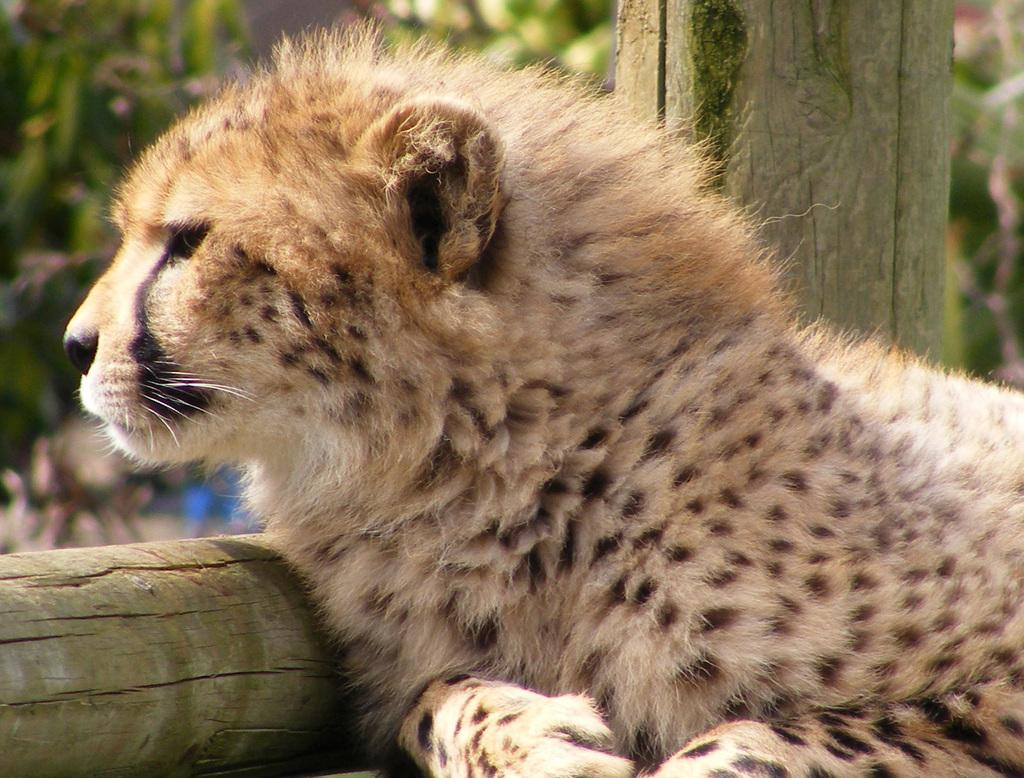What animal is the main subject of the image? There is a leopard in the image. What surface is the leopard on? The leopard is on wood. Can you describe any other objects or features in the image? There is a stem in the top right of the image. How would you describe the overall appearance of the image? The background of the image is blurred. What group of people is shown experiencing a loss in the image? There are no people or any indication of loss in the image; it features a leopard on wood with a blurred background. Can you see the sea in the image? No, the sea is not visible in the image; it only shows a leopard on wood with a blurred background. 